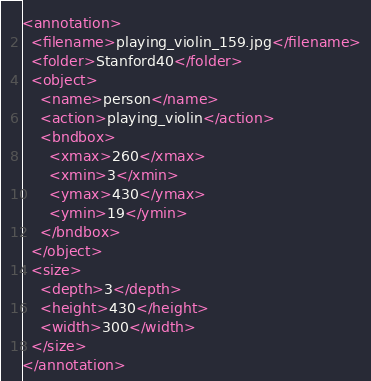<code> <loc_0><loc_0><loc_500><loc_500><_XML_><annotation>
  <filename>playing_violin_159.jpg</filename>
  <folder>Stanford40</folder>
  <object>
    <name>person</name>
    <action>playing_violin</action>
    <bndbox>
      <xmax>260</xmax>
      <xmin>3</xmin>
      <ymax>430</ymax>
      <ymin>19</ymin>
    </bndbox>
  </object>
  <size>
    <depth>3</depth>
    <height>430</height>
    <width>300</width>
  </size>
</annotation>
</code> 